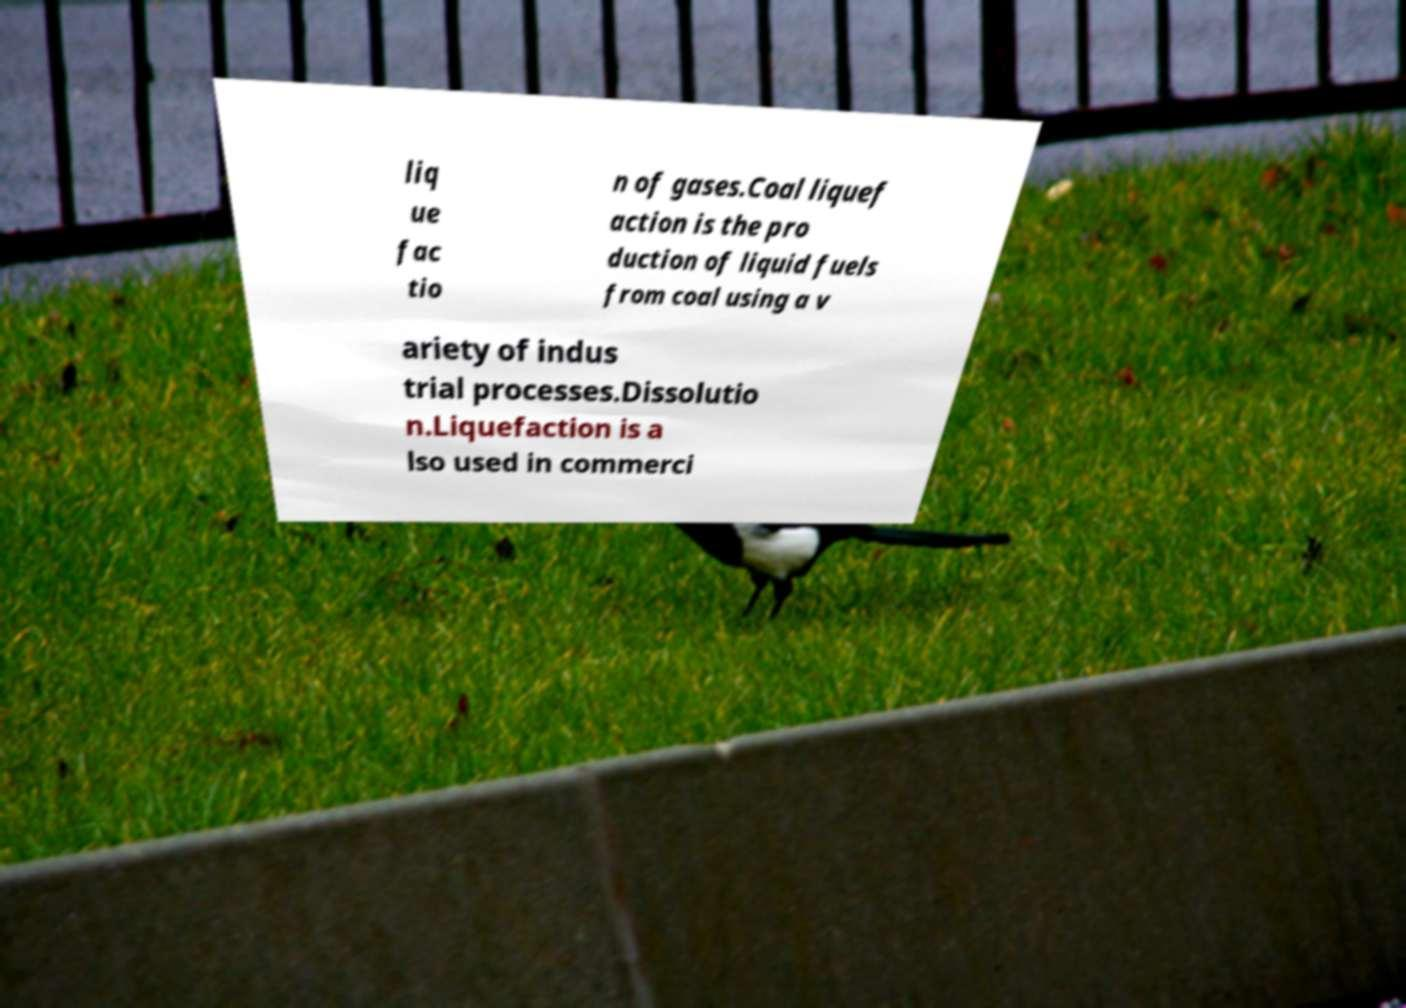Could you assist in decoding the text presented in this image and type it out clearly? liq ue fac tio n of gases.Coal liquef action is the pro duction of liquid fuels from coal using a v ariety of indus trial processes.Dissolutio n.Liquefaction is a lso used in commerci 